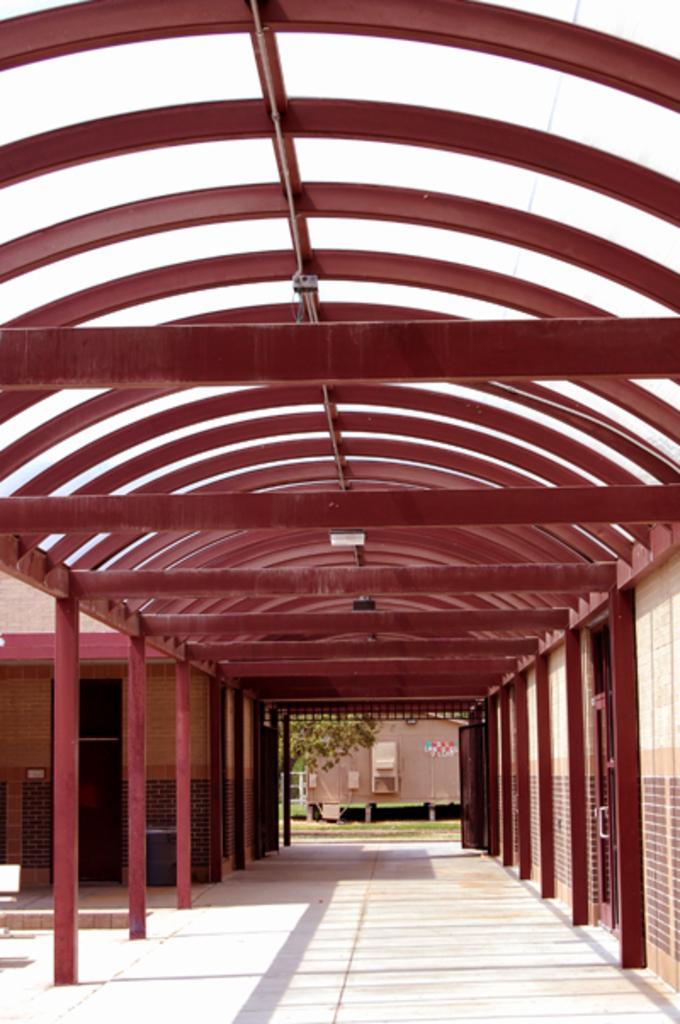Describe this image in one or two sentences. In this picture we can see a few poles on the right and left side of the path. We can see a house on the left side. There is a door and a door handle on the right side. We can see a plant and some grass on the ground. There is a house and other objects in the background. 